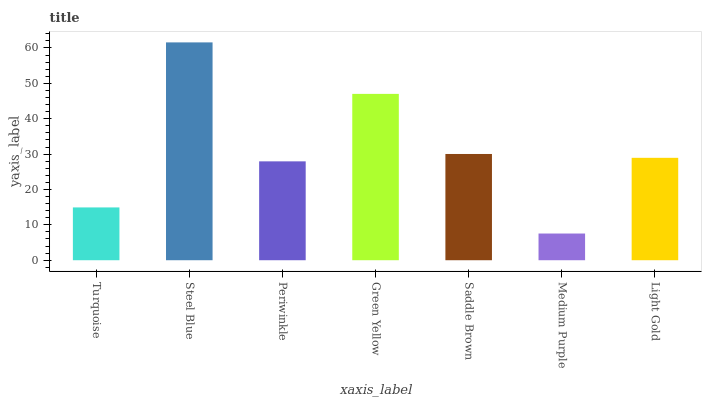Is Medium Purple the minimum?
Answer yes or no. Yes. Is Steel Blue the maximum?
Answer yes or no. Yes. Is Periwinkle the minimum?
Answer yes or no. No. Is Periwinkle the maximum?
Answer yes or no. No. Is Steel Blue greater than Periwinkle?
Answer yes or no. Yes. Is Periwinkle less than Steel Blue?
Answer yes or no. Yes. Is Periwinkle greater than Steel Blue?
Answer yes or no. No. Is Steel Blue less than Periwinkle?
Answer yes or no. No. Is Light Gold the high median?
Answer yes or no. Yes. Is Light Gold the low median?
Answer yes or no. Yes. Is Periwinkle the high median?
Answer yes or no. No. Is Steel Blue the low median?
Answer yes or no. No. 